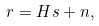Convert formula to latex. <formula><loc_0><loc_0><loc_500><loc_500>r = H s + n ,</formula> 